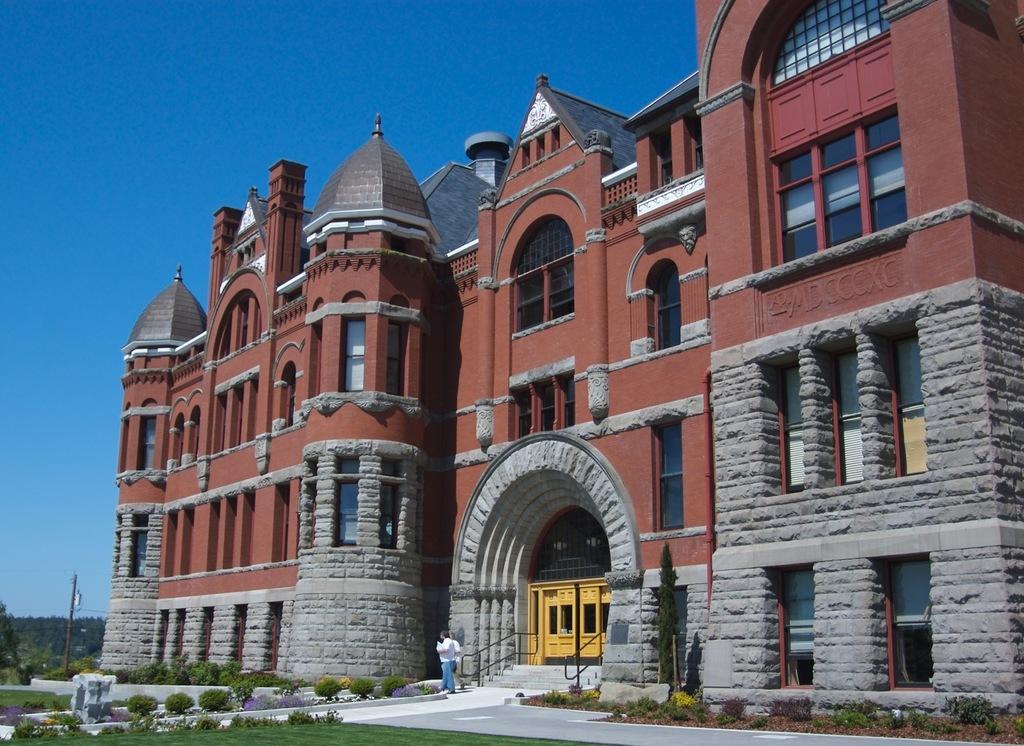In one or two sentences, can you explain what this image depicts? In this image I can see a person wearing white shirt and blue jeans is standing and few plants, some grass, few stairs and the black colored railing. I can see the building which is brown and ash in color and a gate which is yellow in color. In the background I can see few trees and the sky. 